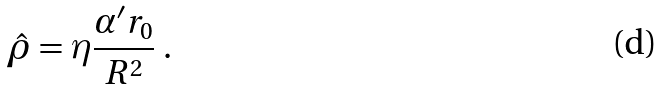<formula> <loc_0><loc_0><loc_500><loc_500>\hat { \rho } = \eta \frac { \alpha ^ { \prime } r _ { 0 } } { R ^ { 2 } } \ .</formula> 